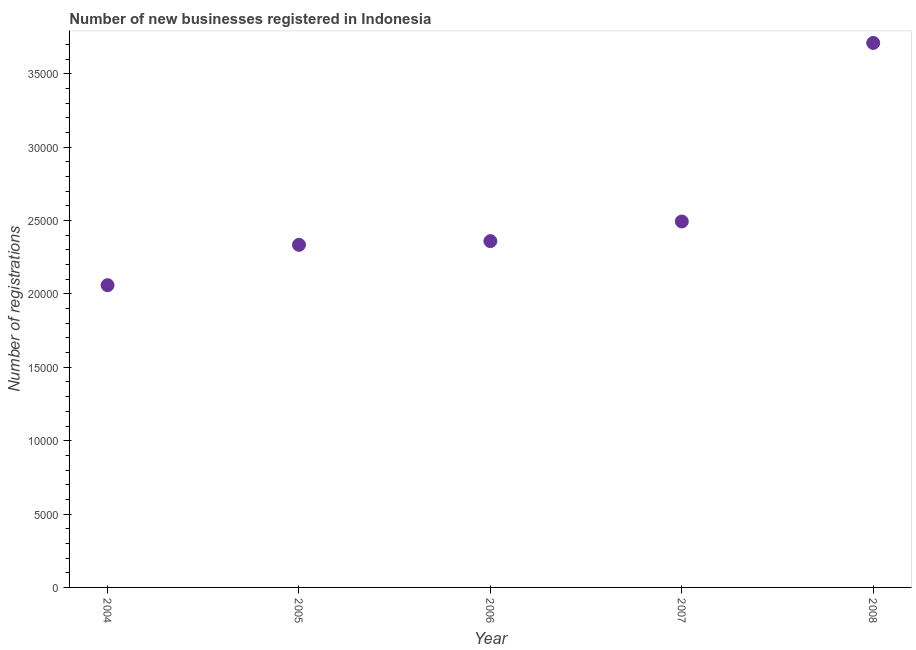What is the number of new business registrations in 2008?
Provide a short and direct response. 3.71e+04. Across all years, what is the maximum number of new business registrations?
Provide a succinct answer. 3.71e+04. Across all years, what is the minimum number of new business registrations?
Offer a very short reply. 2.06e+04. In which year was the number of new business registrations maximum?
Offer a very short reply. 2008. In which year was the number of new business registrations minimum?
Keep it short and to the point. 2004. What is the sum of the number of new business registrations?
Make the answer very short. 1.30e+05. What is the difference between the number of new business registrations in 2005 and 2006?
Offer a very short reply. -251. What is the average number of new business registrations per year?
Provide a succinct answer. 2.59e+04. What is the median number of new business registrations?
Give a very brief answer. 2.36e+04. In how many years, is the number of new business registrations greater than 24000 ?
Keep it short and to the point. 2. What is the ratio of the number of new business registrations in 2004 to that in 2006?
Offer a very short reply. 0.87. Is the number of new business registrations in 2004 less than that in 2005?
Give a very brief answer. Yes. Is the difference between the number of new business registrations in 2004 and 2007 greater than the difference between any two years?
Make the answer very short. No. What is the difference between the highest and the second highest number of new business registrations?
Offer a terse response. 1.22e+04. What is the difference between the highest and the lowest number of new business registrations?
Provide a short and direct response. 1.65e+04. What is the title of the graph?
Your response must be concise. Number of new businesses registered in Indonesia. What is the label or title of the Y-axis?
Provide a short and direct response. Number of registrations. What is the Number of registrations in 2004?
Your answer should be very brief. 2.06e+04. What is the Number of registrations in 2005?
Give a very brief answer. 2.33e+04. What is the Number of registrations in 2006?
Your response must be concise. 2.36e+04. What is the Number of registrations in 2007?
Offer a very short reply. 2.49e+04. What is the Number of registrations in 2008?
Ensure brevity in your answer.  3.71e+04. What is the difference between the Number of registrations in 2004 and 2005?
Give a very brief answer. -2750. What is the difference between the Number of registrations in 2004 and 2006?
Keep it short and to the point. -3001. What is the difference between the Number of registrations in 2004 and 2007?
Offer a terse response. -4340. What is the difference between the Number of registrations in 2004 and 2008?
Make the answer very short. -1.65e+04. What is the difference between the Number of registrations in 2005 and 2006?
Offer a very short reply. -251. What is the difference between the Number of registrations in 2005 and 2007?
Offer a very short reply. -1590. What is the difference between the Number of registrations in 2005 and 2008?
Offer a terse response. -1.38e+04. What is the difference between the Number of registrations in 2006 and 2007?
Provide a short and direct response. -1339. What is the difference between the Number of registrations in 2006 and 2008?
Give a very brief answer. -1.35e+04. What is the difference between the Number of registrations in 2007 and 2008?
Your answer should be compact. -1.22e+04. What is the ratio of the Number of registrations in 2004 to that in 2005?
Your answer should be very brief. 0.88. What is the ratio of the Number of registrations in 2004 to that in 2006?
Offer a terse response. 0.87. What is the ratio of the Number of registrations in 2004 to that in 2007?
Your answer should be very brief. 0.83. What is the ratio of the Number of registrations in 2004 to that in 2008?
Provide a short and direct response. 0.56. What is the ratio of the Number of registrations in 2005 to that in 2006?
Make the answer very short. 0.99. What is the ratio of the Number of registrations in 2005 to that in 2007?
Keep it short and to the point. 0.94. What is the ratio of the Number of registrations in 2005 to that in 2008?
Keep it short and to the point. 0.63. What is the ratio of the Number of registrations in 2006 to that in 2007?
Your response must be concise. 0.95. What is the ratio of the Number of registrations in 2006 to that in 2008?
Give a very brief answer. 0.64. What is the ratio of the Number of registrations in 2007 to that in 2008?
Ensure brevity in your answer.  0.67. 